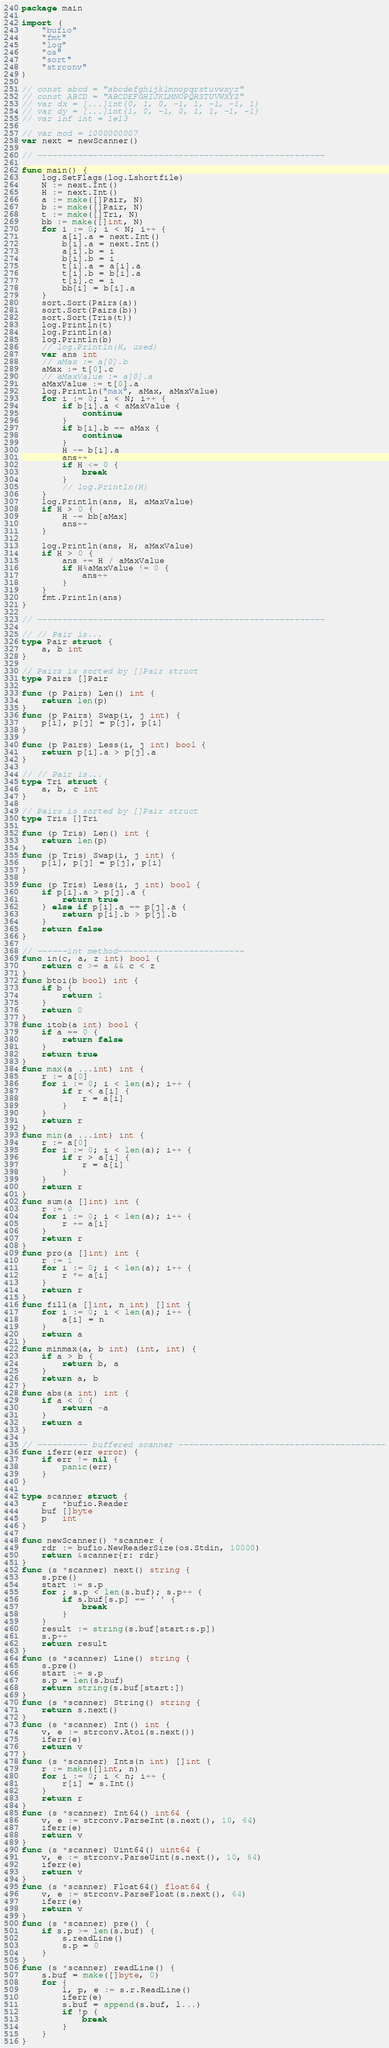<code> <loc_0><loc_0><loc_500><loc_500><_Go_>package main

import (
	"bufio"
	"fmt"
	"log"
	"os"
	"sort"
	"strconv"
)

// const abcd = "abcdefghijklmnopqrstuvwxyz"
// const ABCD = "ABCDEFGHIJKLMNOPQRSTUVWXYZ"
// var dx = [...]int{0, 1, 0, -1, 1, -1, -1, 1}
// var dy = [...]int{1, 0, -1, 0, 1, 1, -1, -1}
// var inf int = 1e13

// var mod = 1000000007
var next = newScanner()

// ---------------------------------------------------------

func main() {
	log.SetFlags(log.Lshortfile)
	N := next.Int()
	H := next.Int()
	a := make([]Pair, N)
	b := make([]Pair, N)
	t := make([]Tri, N)
	bb := make([]int, N)
	for i := 0; i < N; i++ {
		a[i].a = next.Int()
		b[i].a = next.Int()
		a[i].b = i
		b[i].b = i
		t[i].a = a[i].a
		t[i].b = b[i].a
		t[i].c = i
		bb[i] = b[i].a
	}
	sort.Sort(Pairs(a))
	sort.Sort(Pairs(b))
	sort.Sort(Tris(t))
	log.Println(t)
	log.Println(a)
	log.Println(b)
	// log.Println(H, used)
	var ans int
	// aMax := a[0].b
	aMax := t[0].c
	// aMaxValue := a[0].a
	aMaxValue := t[0].a
	log.Println("max", aMax, aMaxValue)
	for i := 0; i < N; i++ {
		if b[i].a < aMaxValue {
			continue
		}
		if b[i].b == aMax {
			continue
		}
		H -= b[i].a
		ans++
		if H <= 0 {
			break
		}
		// log.Println(H)
	}
	log.Println(ans, H, aMaxValue)
	if H > 0 {
		H -= bb[aMax]
		ans++
	}

	log.Println(ans, H, aMaxValue)
	if H > 0 {
		ans += H / aMaxValue
		if H%aMaxValue != 0 {
			ans++
		}
	}
	fmt.Println(ans)
}

// ---------------------------------------------------------

// // Pair is...
type Pair struct {
	a, b int
}

// Pairs is sorted by []Pair struct
type Pairs []Pair

func (p Pairs) Len() int {
	return len(p)
}
func (p Pairs) Swap(i, j int) {
	p[i], p[j] = p[j], p[i]
}

func (p Pairs) Less(i, j int) bool {
	return p[i].a > p[j].a
}

// // Pair is...
type Tri struct {
	a, b, c int
}

// Pairs is sorted by []Pair struct
type Tris []Tri

func (p Tris) Len() int {
	return len(p)
}
func (p Tris) Swap(i, j int) {
	p[i], p[j] = p[j], p[i]
}

func (p Tris) Less(i, j int) bool {
	if p[i].a > p[j].a {
		return true
	} else if p[i].a == p[j].a {
		return p[i].b > p[j].b
	}
	return false
}

// ------int method-------------------------
func in(c, a, z int) bool {
	return c >= a && c < z
}
func btoi(b bool) int {
	if b {
		return 1
	}
	return 0
}
func itob(a int) bool {
	if a == 0 {
		return false
	}
	return true
}
func max(a ...int) int {
	r := a[0]
	for i := 0; i < len(a); i++ {
		if r < a[i] {
			r = a[i]
		}
	}
	return r
}
func min(a ...int) int {
	r := a[0]
	for i := 0; i < len(a); i++ {
		if r > a[i] {
			r = a[i]
		}
	}
	return r
}
func sum(a []int) int {
	r := 0
	for i := 0; i < len(a); i++ {
		r += a[i]
	}
	return r
}
func pro(a []int) int {
	r := 1
	for i := 0; i < len(a); i++ {
		r *= a[i]
	}
	return r
}
func fill(a []int, n int) []int {
	for i := 0; i < len(a); i++ {
		a[i] = n
	}
	return a
}
func minmax(a, b int) (int, int) {
	if a > b {
		return b, a
	}
	return a, b
}
func abs(a int) int {
	if a < 0 {
		return -a
	}
	return a
}

// ---------- buffered scanner -----------------------------------------
func iferr(err error) {
	if err != nil {
		panic(err)
	}
}

type scanner struct {
	r   *bufio.Reader
	buf []byte
	p   int
}

func newScanner() *scanner {
	rdr := bufio.NewReaderSize(os.Stdin, 10000)
	return &scanner{r: rdr}
}
func (s *scanner) next() string {
	s.pre()
	start := s.p
	for ; s.p < len(s.buf); s.p++ {
		if s.buf[s.p] == ' ' {
			break
		}
	}
	result := string(s.buf[start:s.p])
	s.p++
	return result
}
func (s *scanner) Line() string {
	s.pre()
	start := s.p
	s.p = len(s.buf)
	return string(s.buf[start:])
}
func (s *scanner) String() string {
	return s.next()
}
func (s *scanner) Int() int {
	v, e := strconv.Atoi(s.next())
	iferr(e)
	return v
}
func (s *scanner) Ints(n int) []int {
	r := make([]int, n)
	for i := 0; i < n; i++ {
		r[i] = s.Int()
	}
	return r
}
func (s *scanner) Int64() int64 {
	v, e := strconv.ParseInt(s.next(), 10, 64)
	iferr(e)
	return v
}
func (s *scanner) Uint64() uint64 {
	v, e := strconv.ParseUint(s.next(), 10, 64)
	iferr(e)
	return v
}
func (s *scanner) Float64() float64 {
	v, e := strconv.ParseFloat(s.next(), 64)
	iferr(e)
	return v
}
func (s *scanner) pre() {
	if s.p >= len(s.buf) {
		s.readLine()
		s.p = 0
	}
}
func (s *scanner) readLine() {
	s.buf = make([]byte, 0)
	for {
		l, p, e := s.r.ReadLine()
		iferr(e)
		s.buf = append(s.buf, l...)
		if !p {
			break
		}
	}
}
</code> 